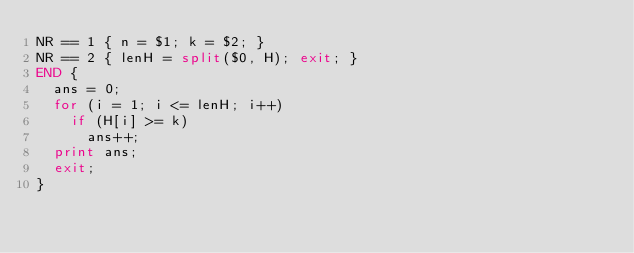<code> <loc_0><loc_0><loc_500><loc_500><_Awk_>NR == 1 { n = $1; k = $2; }
NR == 2 { lenH = split($0, H); exit; }
END {
  ans = 0;
  for (i = 1; i <= lenH; i++)
    if (H[i] >= k)
      ans++;
  print ans;
  exit;
}
</code> 